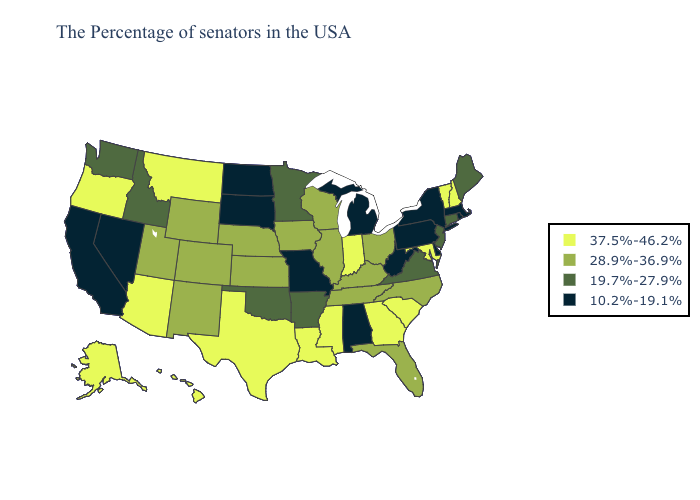What is the highest value in the USA?
Concise answer only. 37.5%-46.2%. Name the states that have a value in the range 10.2%-19.1%?
Keep it brief. Massachusetts, Rhode Island, New York, Delaware, Pennsylvania, West Virginia, Michigan, Alabama, Missouri, South Dakota, North Dakota, Nevada, California. Does North Carolina have the lowest value in the South?
Write a very short answer. No. What is the value of Hawaii?
Quick response, please. 37.5%-46.2%. Does Maine have the highest value in the Northeast?
Write a very short answer. No. What is the highest value in the USA?
Short answer required. 37.5%-46.2%. What is the value of Alabama?
Give a very brief answer. 10.2%-19.1%. What is the value of Maine?
Be succinct. 19.7%-27.9%. Name the states that have a value in the range 19.7%-27.9%?
Short answer required. Maine, Connecticut, New Jersey, Virginia, Arkansas, Minnesota, Oklahoma, Idaho, Washington. What is the highest value in states that border Connecticut?
Quick response, please. 10.2%-19.1%. Name the states that have a value in the range 19.7%-27.9%?
Give a very brief answer. Maine, Connecticut, New Jersey, Virginia, Arkansas, Minnesota, Oklahoma, Idaho, Washington. Among the states that border Massachusetts , does New York have the lowest value?
Short answer required. Yes. Does the map have missing data?
Be succinct. No. What is the lowest value in the MidWest?
Concise answer only. 10.2%-19.1%. Does Illinois have the same value as North Dakota?
Quick response, please. No. 